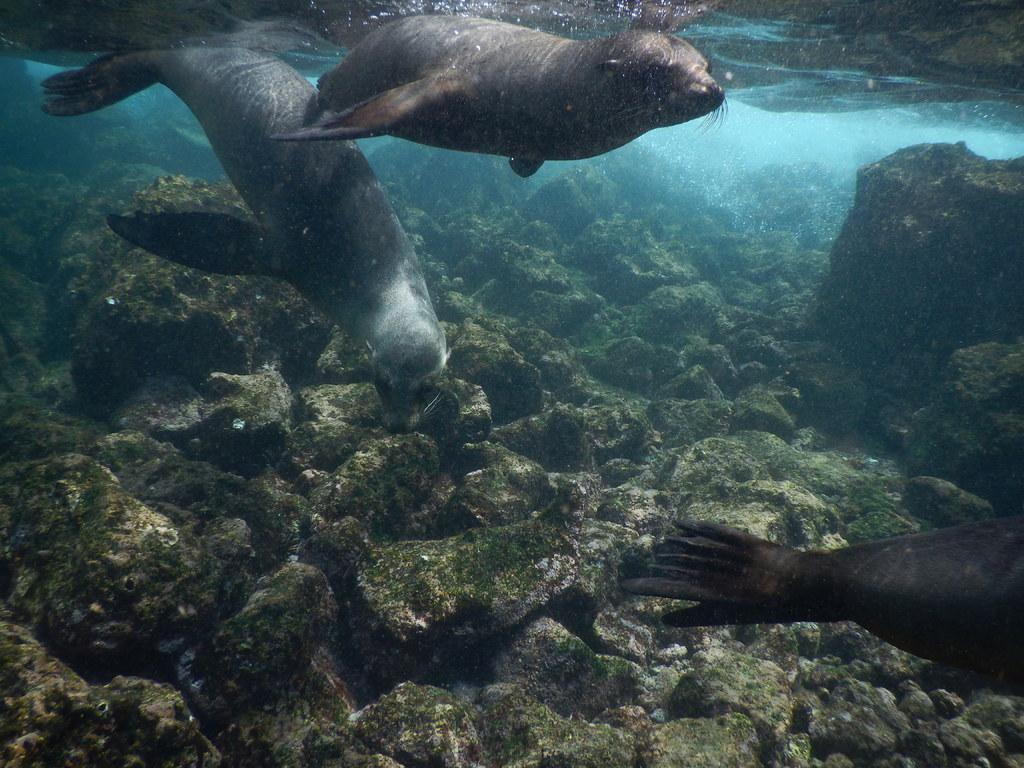What animals can be seen in the image? There are sea lions in the image. What are the sea lions doing in the image? The sea lions are swimming in the water. What type of environment is visible at the bottom of the image? There is grass and stones visible at the bottom of the image. What type of plants can be seen growing in the hall in the image? There is no hall or plants present in the image; it features sea lions swimming in the water with grass and stones visible at the bottom. 